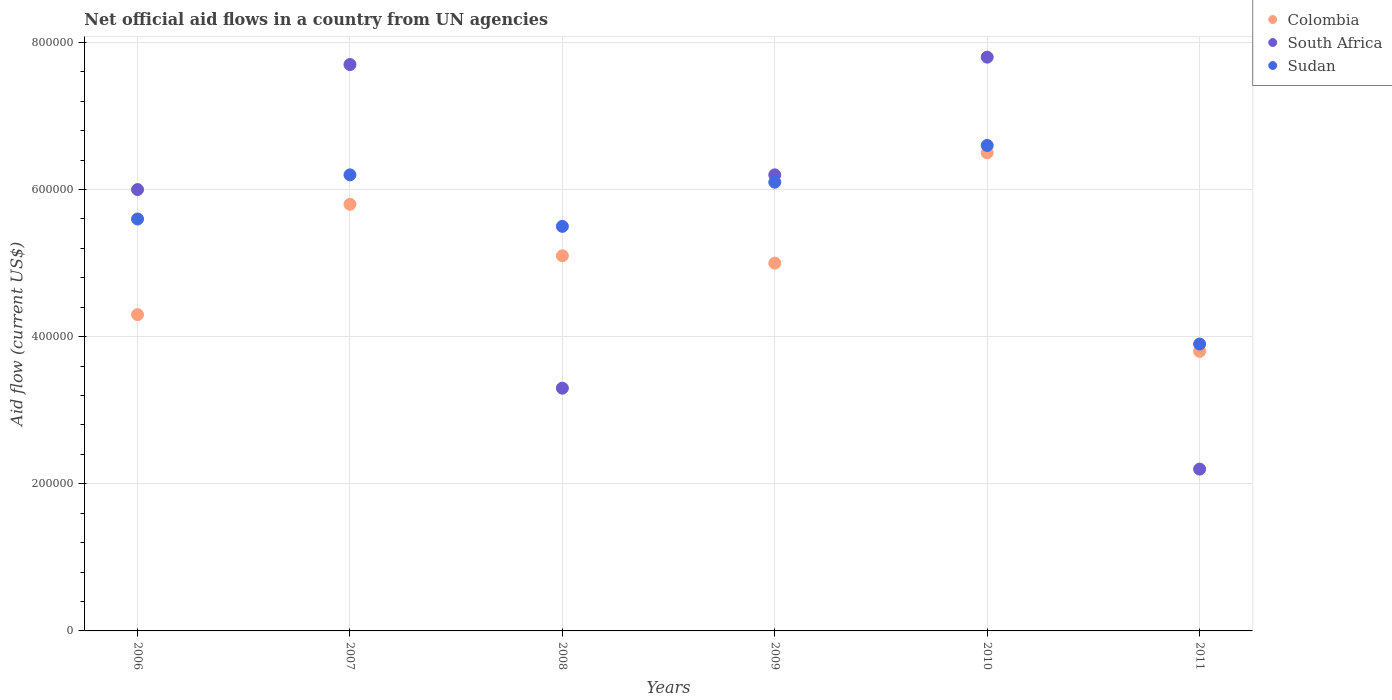What is the net official aid flow in Colombia in 2008?
Provide a short and direct response. 5.10e+05. Across all years, what is the maximum net official aid flow in South Africa?
Make the answer very short. 7.80e+05. Across all years, what is the minimum net official aid flow in Colombia?
Your response must be concise. 3.80e+05. In which year was the net official aid flow in South Africa maximum?
Your answer should be compact. 2010. In which year was the net official aid flow in Sudan minimum?
Keep it short and to the point. 2011. What is the total net official aid flow in Sudan in the graph?
Give a very brief answer. 3.39e+06. What is the difference between the net official aid flow in Colombia in 2006 and that in 2009?
Your answer should be compact. -7.00e+04. What is the difference between the net official aid flow in South Africa in 2006 and the net official aid flow in Sudan in 2010?
Provide a short and direct response. -6.00e+04. What is the average net official aid flow in South Africa per year?
Provide a succinct answer. 5.53e+05. In the year 2006, what is the difference between the net official aid flow in South Africa and net official aid flow in Colombia?
Provide a succinct answer. 1.70e+05. What is the ratio of the net official aid flow in Colombia in 2010 to that in 2011?
Give a very brief answer. 1.71. Is the difference between the net official aid flow in South Africa in 2009 and 2010 greater than the difference between the net official aid flow in Colombia in 2009 and 2010?
Your answer should be very brief. No. What is the difference between the highest and the second highest net official aid flow in South Africa?
Make the answer very short. 10000. What is the difference between the highest and the lowest net official aid flow in South Africa?
Your response must be concise. 5.60e+05. In how many years, is the net official aid flow in Sudan greater than the average net official aid flow in Sudan taken over all years?
Offer a terse response. 3. Is it the case that in every year, the sum of the net official aid flow in Sudan and net official aid flow in Colombia  is greater than the net official aid flow in South Africa?
Provide a short and direct response. Yes. Is the net official aid flow in South Africa strictly greater than the net official aid flow in Sudan over the years?
Offer a very short reply. No. Is the net official aid flow in Sudan strictly less than the net official aid flow in South Africa over the years?
Keep it short and to the point. No. What is the difference between two consecutive major ticks on the Y-axis?
Offer a terse response. 2.00e+05. Are the values on the major ticks of Y-axis written in scientific E-notation?
Keep it short and to the point. No. Where does the legend appear in the graph?
Offer a terse response. Top right. How are the legend labels stacked?
Offer a terse response. Vertical. What is the title of the graph?
Keep it short and to the point. Net official aid flows in a country from UN agencies. Does "Afghanistan" appear as one of the legend labels in the graph?
Your answer should be compact. No. What is the Aid flow (current US$) in Colombia in 2006?
Your response must be concise. 4.30e+05. What is the Aid flow (current US$) in Sudan in 2006?
Your response must be concise. 5.60e+05. What is the Aid flow (current US$) of Colombia in 2007?
Your answer should be very brief. 5.80e+05. What is the Aid flow (current US$) of South Africa in 2007?
Keep it short and to the point. 7.70e+05. What is the Aid flow (current US$) of Sudan in 2007?
Your response must be concise. 6.20e+05. What is the Aid flow (current US$) of Colombia in 2008?
Your answer should be compact. 5.10e+05. What is the Aid flow (current US$) of South Africa in 2008?
Give a very brief answer. 3.30e+05. What is the Aid flow (current US$) in Sudan in 2008?
Your answer should be very brief. 5.50e+05. What is the Aid flow (current US$) in South Africa in 2009?
Provide a short and direct response. 6.20e+05. What is the Aid flow (current US$) of Colombia in 2010?
Provide a succinct answer. 6.50e+05. What is the Aid flow (current US$) in South Africa in 2010?
Your answer should be very brief. 7.80e+05. What is the Aid flow (current US$) in Sudan in 2010?
Make the answer very short. 6.60e+05. What is the Aid flow (current US$) of Colombia in 2011?
Provide a short and direct response. 3.80e+05. What is the Aid flow (current US$) of South Africa in 2011?
Ensure brevity in your answer.  2.20e+05. Across all years, what is the maximum Aid flow (current US$) of Colombia?
Give a very brief answer. 6.50e+05. Across all years, what is the maximum Aid flow (current US$) of South Africa?
Ensure brevity in your answer.  7.80e+05. Across all years, what is the maximum Aid flow (current US$) in Sudan?
Keep it short and to the point. 6.60e+05. Across all years, what is the minimum Aid flow (current US$) in South Africa?
Your answer should be compact. 2.20e+05. What is the total Aid flow (current US$) of Colombia in the graph?
Provide a succinct answer. 3.05e+06. What is the total Aid flow (current US$) in South Africa in the graph?
Offer a very short reply. 3.32e+06. What is the total Aid flow (current US$) in Sudan in the graph?
Ensure brevity in your answer.  3.39e+06. What is the difference between the Aid flow (current US$) of Colombia in 2006 and that in 2007?
Offer a terse response. -1.50e+05. What is the difference between the Aid flow (current US$) in South Africa in 2006 and that in 2007?
Your response must be concise. -1.70e+05. What is the difference between the Aid flow (current US$) in Sudan in 2006 and that in 2008?
Provide a succinct answer. 10000. What is the difference between the Aid flow (current US$) of Colombia in 2006 and that in 2009?
Ensure brevity in your answer.  -7.00e+04. What is the difference between the Aid flow (current US$) of Colombia in 2006 and that in 2010?
Offer a very short reply. -2.20e+05. What is the difference between the Aid flow (current US$) in Sudan in 2006 and that in 2010?
Offer a terse response. -1.00e+05. What is the difference between the Aid flow (current US$) of Colombia in 2006 and that in 2011?
Ensure brevity in your answer.  5.00e+04. What is the difference between the Aid flow (current US$) of South Africa in 2006 and that in 2011?
Your answer should be compact. 3.80e+05. What is the difference between the Aid flow (current US$) of South Africa in 2007 and that in 2008?
Offer a terse response. 4.40e+05. What is the difference between the Aid flow (current US$) in Colombia in 2007 and that in 2009?
Offer a very short reply. 8.00e+04. What is the difference between the Aid flow (current US$) of South Africa in 2007 and that in 2009?
Make the answer very short. 1.50e+05. What is the difference between the Aid flow (current US$) of Sudan in 2007 and that in 2009?
Offer a terse response. 10000. What is the difference between the Aid flow (current US$) of Colombia in 2007 and that in 2010?
Ensure brevity in your answer.  -7.00e+04. What is the difference between the Aid flow (current US$) in South Africa in 2007 and that in 2010?
Your answer should be compact. -10000. What is the difference between the Aid flow (current US$) of Colombia in 2007 and that in 2011?
Give a very brief answer. 2.00e+05. What is the difference between the Aid flow (current US$) in Sudan in 2007 and that in 2011?
Your answer should be compact. 2.30e+05. What is the difference between the Aid flow (current US$) of South Africa in 2008 and that in 2009?
Make the answer very short. -2.90e+05. What is the difference between the Aid flow (current US$) in Colombia in 2008 and that in 2010?
Make the answer very short. -1.40e+05. What is the difference between the Aid flow (current US$) of South Africa in 2008 and that in 2010?
Offer a terse response. -4.50e+05. What is the difference between the Aid flow (current US$) of Colombia in 2008 and that in 2011?
Give a very brief answer. 1.30e+05. What is the difference between the Aid flow (current US$) in South Africa in 2008 and that in 2011?
Offer a terse response. 1.10e+05. What is the difference between the Aid flow (current US$) in Sudan in 2008 and that in 2011?
Give a very brief answer. 1.60e+05. What is the difference between the Aid flow (current US$) of Colombia in 2009 and that in 2010?
Your answer should be very brief. -1.50e+05. What is the difference between the Aid flow (current US$) of South Africa in 2009 and that in 2010?
Your response must be concise. -1.60e+05. What is the difference between the Aid flow (current US$) in South Africa in 2009 and that in 2011?
Keep it short and to the point. 4.00e+05. What is the difference between the Aid flow (current US$) in South Africa in 2010 and that in 2011?
Your answer should be very brief. 5.60e+05. What is the difference between the Aid flow (current US$) in Sudan in 2010 and that in 2011?
Give a very brief answer. 2.70e+05. What is the difference between the Aid flow (current US$) in Colombia in 2006 and the Aid flow (current US$) in South Africa in 2009?
Keep it short and to the point. -1.90e+05. What is the difference between the Aid flow (current US$) of Colombia in 2006 and the Aid flow (current US$) of Sudan in 2009?
Make the answer very short. -1.80e+05. What is the difference between the Aid flow (current US$) in South Africa in 2006 and the Aid flow (current US$) in Sudan in 2009?
Offer a very short reply. -10000. What is the difference between the Aid flow (current US$) of Colombia in 2006 and the Aid flow (current US$) of South Africa in 2010?
Provide a short and direct response. -3.50e+05. What is the difference between the Aid flow (current US$) in Colombia in 2006 and the Aid flow (current US$) in Sudan in 2010?
Provide a short and direct response. -2.30e+05. What is the difference between the Aid flow (current US$) in Colombia in 2006 and the Aid flow (current US$) in South Africa in 2011?
Keep it short and to the point. 2.10e+05. What is the difference between the Aid flow (current US$) of South Africa in 2006 and the Aid flow (current US$) of Sudan in 2011?
Your answer should be compact. 2.10e+05. What is the difference between the Aid flow (current US$) of Colombia in 2007 and the Aid flow (current US$) of South Africa in 2008?
Your answer should be very brief. 2.50e+05. What is the difference between the Aid flow (current US$) in Colombia in 2007 and the Aid flow (current US$) in Sudan in 2008?
Ensure brevity in your answer.  3.00e+04. What is the difference between the Aid flow (current US$) in Colombia in 2007 and the Aid flow (current US$) in South Africa in 2009?
Make the answer very short. -4.00e+04. What is the difference between the Aid flow (current US$) in South Africa in 2007 and the Aid flow (current US$) in Sudan in 2010?
Offer a very short reply. 1.10e+05. What is the difference between the Aid flow (current US$) of Colombia in 2007 and the Aid flow (current US$) of Sudan in 2011?
Offer a terse response. 1.90e+05. What is the difference between the Aid flow (current US$) in South Africa in 2008 and the Aid flow (current US$) in Sudan in 2009?
Give a very brief answer. -2.80e+05. What is the difference between the Aid flow (current US$) in Colombia in 2008 and the Aid flow (current US$) in Sudan in 2010?
Your answer should be very brief. -1.50e+05. What is the difference between the Aid flow (current US$) in South Africa in 2008 and the Aid flow (current US$) in Sudan in 2010?
Ensure brevity in your answer.  -3.30e+05. What is the difference between the Aid flow (current US$) in Colombia in 2008 and the Aid flow (current US$) in South Africa in 2011?
Keep it short and to the point. 2.90e+05. What is the difference between the Aid flow (current US$) in Colombia in 2008 and the Aid flow (current US$) in Sudan in 2011?
Make the answer very short. 1.20e+05. What is the difference between the Aid flow (current US$) in South Africa in 2008 and the Aid flow (current US$) in Sudan in 2011?
Provide a short and direct response. -6.00e+04. What is the difference between the Aid flow (current US$) in Colombia in 2009 and the Aid flow (current US$) in South Africa in 2010?
Your answer should be compact. -2.80e+05. What is the difference between the Aid flow (current US$) in Colombia in 2009 and the Aid flow (current US$) in Sudan in 2010?
Offer a terse response. -1.60e+05. What is the difference between the Aid flow (current US$) of Colombia in 2009 and the Aid flow (current US$) of South Africa in 2011?
Your answer should be very brief. 2.80e+05. What is the difference between the Aid flow (current US$) in South Africa in 2009 and the Aid flow (current US$) in Sudan in 2011?
Your answer should be compact. 2.30e+05. What is the difference between the Aid flow (current US$) in Colombia in 2010 and the Aid flow (current US$) in South Africa in 2011?
Offer a terse response. 4.30e+05. What is the difference between the Aid flow (current US$) in Colombia in 2010 and the Aid flow (current US$) in Sudan in 2011?
Ensure brevity in your answer.  2.60e+05. What is the difference between the Aid flow (current US$) of South Africa in 2010 and the Aid flow (current US$) of Sudan in 2011?
Provide a succinct answer. 3.90e+05. What is the average Aid flow (current US$) in Colombia per year?
Offer a terse response. 5.08e+05. What is the average Aid flow (current US$) in South Africa per year?
Provide a succinct answer. 5.53e+05. What is the average Aid flow (current US$) in Sudan per year?
Your answer should be very brief. 5.65e+05. In the year 2006, what is the difference between the Aid flow (current US$) in Colombia and Aid flow (current US$) in South Africa?
Give a very brief answer. -1.70e+05. In the year 2006, what is the difference between the Aid flow (current US$) in Colombia and Aid flow (current US$) in Sudan?
Offer a very short reply. -1.30e+05. In the year 2006, what is the difference between the Aid flow (current US$) of South Africa and Aid flow (current US$) of Sudan?
Keep it short and to the point. 4.00e+04. In the year 2007, what is the difference between the Aid flow (current US$) of Colombia and Aid flow (current US$) of Sudan?
Provide a short and direct response. -4.00e+04. In the year 2008, what is the difference between the Aid flow (current US$) of Colombia and Aid flow (current US$) of Sudan?
Give a very brief answer. -4.00e+04. In the year 2009, what is the difference between the Aid flow (current US$) of South Africa and Aid flow (current US$) of Sudan?
Offer a very short reply. 10000. In the year 2010, what is the difference between the Aid flow (current US$) in Colombia and Aid flow (current US$) in South Africa?
Ensure brevity in your answer.  -1.30e+05. In the year 2010, what is the difference between the Aid flow (current US$) of Colombia and Aid flow (current US$) of Sudan?
Ensure brevity in your answer.  -10000. In the year 2010, what is the difference between the Aid flow (current US$) in South Africa and Aid flow (current US$) in Sudan?
Ensure brevity in your answer.  1.20e+05. In the year 2011, what is the difference between the Aid flow (current US$) of South Africa and Aid flow (current US$) of Sudan?
Your answer should be compact. -1.70e+05. What is the ratio of the Aid flow (current US$) of Colombia in 2006 to that in 2007?
Provide a short and direct response. 0.74. What is the ratio of the Aid flow (current US$) of South Africa in 2006 to that in 2007?
Provide a short and direct response. 0.78. What is the ratio of the Aid flow (current US$) of Sudan in 2006 to that in 2007?
Your answer should be compact. 0.9. What is the ratio of the Aid flow (current US$) of Colombia in 2006 to that in 2008?
Offer a terse response. 0.84. What is the ratio of the Aid flow (current US$) of South Africa in 2006 to that in 2008?
Make the answer very short. 1.82. What is the ratio of the Aid flow (current US$) of Sudan in 2006 to that in 2008?
Your answer should be very brief. 1.02. What is the ratio of the Aid flow (current US$) of Colombia in 2006 to that in 2009?
Ensure brevity in your answer.  0.86. What is the ratio of the Aid flow (current US$) in Sudan in 2006 to that in 2009?
Ensure brevity in your answer.  0.92. What is the ratio of the Aid flow (current US$) of Colombia in 2006 to that in 2010?
Your response must be concise. 0.66. What is the ratio of the Aid flow (current US$) in South Africa in 2006 to that in 2010?
Offer a very short reply. 0.77. What is the ratio of the Aid flow (current US$) of Sudan in 2006 to that in 2010?
Your answer should be very brief. 0.85. What is the ratio of the Aid flow (current US$) of Colombia in 2006 to that in 2011?
Keep it short and to the point. 1.13. What is the ratio of the Aid flow (current US$) in South Africa in 2006 to that in 2011?
Offer a very short reply. 2.73. What is the ratio of the Aid flow (current US$) of Sudan in 2006 to that in 2011?
Your answer should be very brief. 1.44. What is the ratio of the Aid flow (current US$) of Colombia in 2007 to that in 2008?
Give a very brief answer. 1.14. What is the ratio of the Aid flow (current US$) of South Africa in 2007 to that in 2008?
Your response must be concise. 2.33. What is the ratio of the Aid flow (current US$) in Sudan in 2007 to that in 2008?
Offer a very short reply. 1.13. What is the ratio of the Aid flow (current US$) in Colombia in 2007 to that in 2009?
Provide a succinct answer. 1.16. What is the ratio of the Aid flow (current US$) of South Africa in 2007 to that in 2009?
Your response must be concise. 1.24. What is the ratio of the Aid flow (current US$) of Sudan in 2007 to that in 2009?
Your answer should be compact. 1.02. What is the ratio of the Aid flow (current US$) in Colombia in 2007 to that in 2010?
Offer a very short reply. 0.89. What is the ratio of the Aid flow (current US$) of South Africa in 2007 to that in 2010?
Provide a short and direct response. 0.99. What is the ratio of the Aid flow (current US$) of Sudan in 2007 to that in 2010?
Offer a very short reply. 0.94. What is the ratio of the Aid flow (current US$) in Colombia in 2007 to that in 2011?
Offer a terse response. 1.53. What is the ratio of the Aid flow (current US$) of Sudan in 2007 to that in 2011?
Give a very brief answer. 1.59. What is the ratio of the Aid flow (current US$) of South Africa in 2008 to that in 2009?
Provide a succinct answer. 0.53. What is the ratio of the Aid flow (current US$) in Sudan in 2008 to that in 2009?
Keep it short and to the point. 0.9. What is the ratio of the Aid flow (current US$) in Colombia in 2008 to that in 2010?
Make the answer very short. 0.78. What is the ratio of the Aid flow (current US$) of South Africa in 2008 to that in 2010?
Your response must be concise. 0.42. What is the ratio of the Aid flow (current US$) in Sudan in 2008 to that in 2010?
Provide a succinct answer. 0.83. What is the ratio of the Aid flow (current US$) in Colombia in 2008 to that in 2011?
Offer a terse response. 1.34. What is the ratio of the Aid flow (current US$) of Sudan in 2008 to that in 2011?
Your answer should be compact. 1.41. What is the ratio of the Aid flow (current US$) of Colombia in 2009 to that in 2010?
Your response must be concise. 0.77. What is the ratio of the Aid flow (current US$) in South Africa in 2009 to that in 2010?
Your answer should be very brief. 0.79. What is the ratio of the Aid flow (current US$) in Sudan in 2009 to that in 2010?
Keep it short and to the point. 0.92. What is the ratio of the Aid flow (current US$) in Colombia in 2009 to that in 2011?
Make the answer very short. 1.32. What is the ratio of the Aid flow (current US$) of South Africa in 2009 to that in 2011?
Make the answer very short. 2.82. What is the ratio of the Aid flow (current US$) in Sudan in 2009 to that in 2011?
Provide a succinct answer. 1.56. What is the ratio of the Aid flow (current US$) of Colombia in 2010 to that in 2011?
Provide a short and direct response. 1.71. What is the ratio of the Aid flow (current US$) in South Africa in 2010 to that in 2011?
Your answer should be compact. 3.55. What is the ratio of the Aid flow (current US$) in Sudan in 2010 to that in 2011?
Ensure brevity in your answer.  1.69. What is the difference between the highest and the second highest Aid flow (current US$) of Colombia?
Your response must be concise. 7.00e+04. What is the difference between the highest and the second highest Aid flow (current US$) in Sudan?
Your response must be concise. 4.00e+04. What is the difference between the highest and the lowest Aid flow (current US$) of Colombia?
Your response must be concise. 2.70e+05. What is the difference between the highest and the lowest Aid flow (current US$) of South Africa?
Provide a short and direct response. 5.60e+05. What is the difference between the highest and the lowest Aid flow (current US$) of Sudan?
Your answer should be very brief. 2.70e+05. 